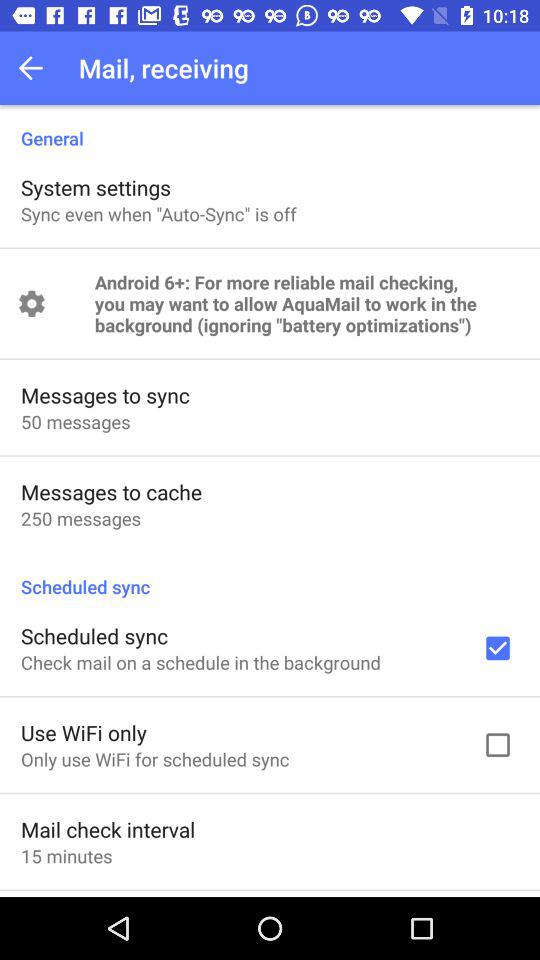What is the status of the "Scheduled sync"? The status is "on". 